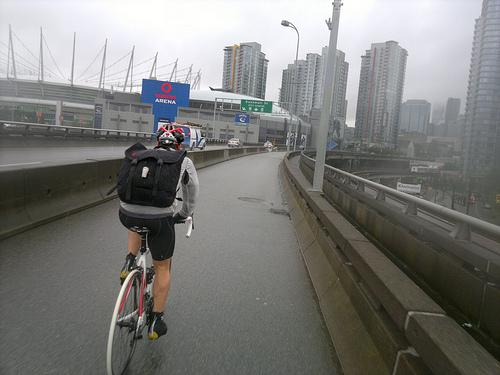Question: where was the photo taken?
Choices:
A. On a riverboat.
B. On the street.
C. In a van.
D. By the ocean.
Answer with the letter. Answer: B Question: what is in the background?
Choices:
A. Dark clouds.
B. Trees.
C. Tall buildings.
D. Buildings and sky.
Answer with the letter. Answer: D Question: who is in the foreground?
Choices:
A. A small boy.
B. A group of children.
C. A cyclist.
D. An old woman.
Answer with the letter. Answer: C Question: what is he doing?
Choices:
A. Painting the house.
B. Riding on a bike path.
C. Walking down the street.
D. Carrying groceries.
Answer with the letter. Answer: B Question: what is on his head?
Choices:
A. A helmet.
B. A cap.
C. A black hat.
D. A bandana.
Answer with the letter. Answer: A Question: what is on his back?
Choices:
A. Golf bag.
B. A backpack.
C. A surf board.
D. A bag of bats.
Answer with the letter. Answer: B Question: what is on the lower level right?
Choices:
A. Train tracks.
B. The highway.
C. The red car.
D. The park.
Answer with the letter. Answer: A 